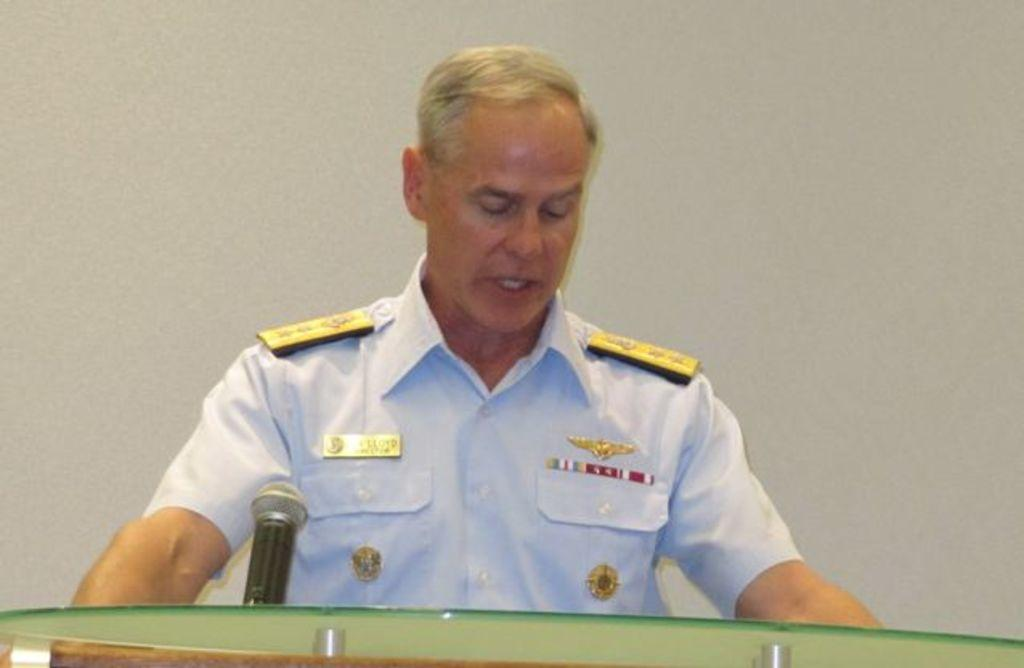Who is present in the image? There is a man in the image. What object is visible in the image that is typically used for amplifying sound? There is a microphone (mike) in the image. What structure can be seen in the image that is often used for public speaking? There is a podium in the image. What is visible in the background of the image? There is a wall in the background of the image. What type of fish can be seen swimming near the wall in the image? There are no fish present in the image; it features a man, a microphone, a podium, and a wall. 